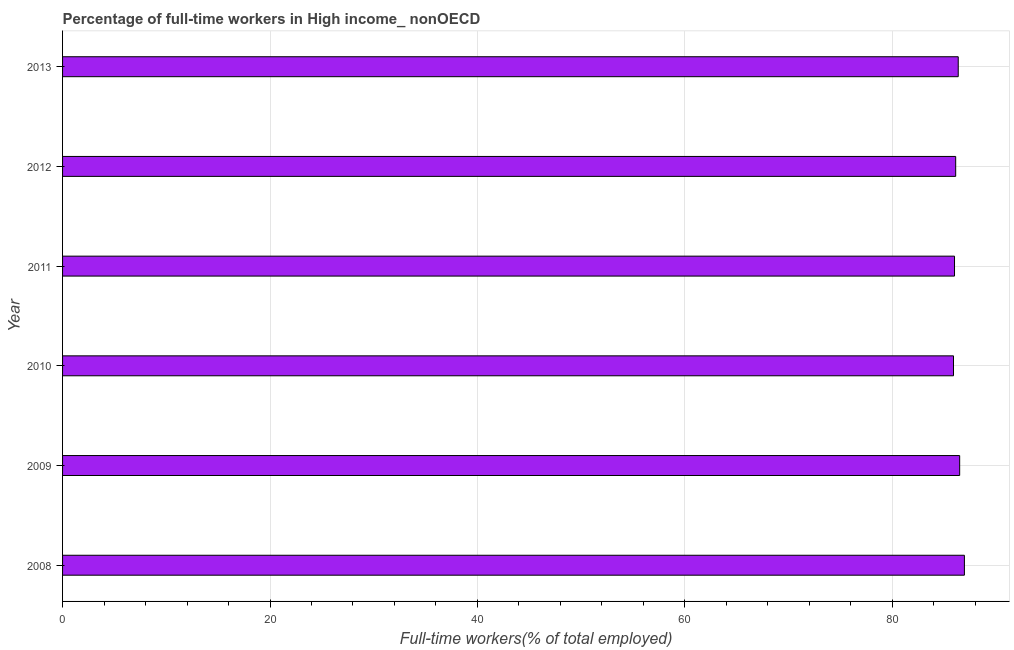Does the graph contain any zero values?
Keep it short and to the point. No. What is the title of the graph?
Offer a very short reply. Percentage of full-time workers in High income_ nonOECD. What is the label or title of the X-axis?
Offer a terse response. Full-time workers(% of total employed). What is the percentage of full-time workers in 2011?
Offer a terse response. 85.99. Across all years, what is the maximum percentage of full-time workers?
Make the answer very short. 86.95. Across all years, what is the minimum percentage of full-time workers?
Ensure brevity in your answer.  85.9. In which year was the percentage of full-time workers minimum?
Your answer should be very brief. 2010. What is the sum of the percentage of full-time workers?
Your answer should be very brief. 517.79. What is the difference between the percentage of full-time workers in 2008 and 2009?
Your answer should be compact. 0.46. What is the average percentage of full-time workers per year?
Provide a short and direct response. 86.3. What is the median percentage of full-time workers?
Your response must be concise. 86.23. In how many years, is the percentage of full-time workers greater than 76 %?
Ensure brevity in your answer.  6. Do a majority of the years between 2009 and 2011 (inclusive) have percentage of full-time workers greater than 16 %?
Your answer should be very brief. Yes. Is the difference between the percentage of full-time workers in 2008 and 2012 greater than the difference between any two years?
Ensure brevity in your answer.  No. What is the difference between the highest and the second highest percentage of full-time workers?
Provide a short and direct response. 0.46. Is the sum of the percentage of full-time workers in 2009 and 2010 greater than the maximum percentage of full-time workers across all years?
Your answer should be compact. Yes. In how many years, is the percentage of full-time workers greater than the average percentage of full-time workers taken over all years?
Offer a terse response. 3. Are all the bars in the graph horizontal?
Ensure brevity in your answer.  Yes. What is the difference between two consecutive major ticks on the X-axis?
Your answer should be very brief. 20. Are the values on the major ticks of X-axis written in scientific E-notation?
Provide a succinct answer. No. What is the Full-time workers(% of total employed) in 2008?
Provide a succinct answer. 86.95. What is the Full-time workers(% of total employed) of 2009?
Ensure brevity in your answer.  86.49. What is the Full-time workers(% of total employed) of 2010?
Keep it short and to the point. 85.9. What is the Full-time workers(% of total employed) in 2011?
Provide a short and direct response. 85.99. What is the Full-time workers(% of total employed) of 2012?
Offer a very short reply. 86.11. What is the Full-time workers(% of total employed) in 2013?
Offer a very short reply. 86.35. What is the difference between the Full-time workers(% of total employed) in 2008 and 2009?
Ensure brevity in your answer.  0.46. What is the difference between the Full-time workers(% of total employed) in 2008 and 2010?
Keep it short and to the point. 1.05. What is the difference between the Full-time workers(% of total employed) in 2008 and 2011?
Provide a short and direct response. 0.95. What is the difference between the Full-time workers(% of total employed) in 2008 and 2012?
Ensure brevity in your answer.  0.84. What is the difference between the Full-time workers(% of total employed) in 2008 and 2013?
Ensure brevity in your answer.  0.59. What is the difference between the Full-time workers(% of total employed) in 2009 and 2010?
Offer a very short reply. 0.6. What is the difference between the Full-time workers(% of total employed) in 2009 and 2011?
Offer a very short reply. 0.5. What is the difference between the Full-time workers(% of total employed) in 2009 and 2012?
Provide a succinct answer. 0.38. What is the difference between the Full-time workers(% of total employed) in 2009 and 2013?
Offer a terse response. 0.14. What is the difference between the Full-time workers(% of total employed) in 2010 and 2011?
Provide a succinct answer. -0.1. What is the difference between the Full-time workers(% of total employed) in 2010 and 2012?
Your answer should be compact. -0.21. What is the difference between the Full-time workers(% of total employed) in 2010 and 2013?
Give a very brief answer. -0.46. What is the difference between the Full-time workers(% of total employed) in 2011 and 2012?
Ensure brevity in your answer.  -0.11. What is the difference between the Full-time workers(% of total employed) in 2011 and 2013?
Offer a very short reply. -0.36. What is the difference between the Full-time workers(% of total employed) in 2012 and 2013?
Keep it short and to the point. -0.24. What is the ratio of the Full-time workers(% of total employed) in 2008 to that in 2013?
Give a very brief answer. 1.01. What is the ratio of the Full-time workers(% of total employed) in 2009 to that in 2010?
Your response must be concise. 1.01. What is the ratio of the Full-time workers(% of total employed) in 2009 to that in 2011?
Make the answer very short. 1.01. What is the ratio of the Full-time workers(% of total employed) in 2010 to that in 2011?
Give a very brief answer. 1. What is the ratio of the Full-time workers(% of total employed) in 2010 to that in 2013?
Provide a succinct answer. 0.99. What is the ratio of the Full-time workers(% of total employed) in 2011 to that in 2012?
Make the answer very short. 1. What is the ratio of the Full-time workers(% of total employed) in 2011 to that in 2013?
Give a very brief answer. 1. 